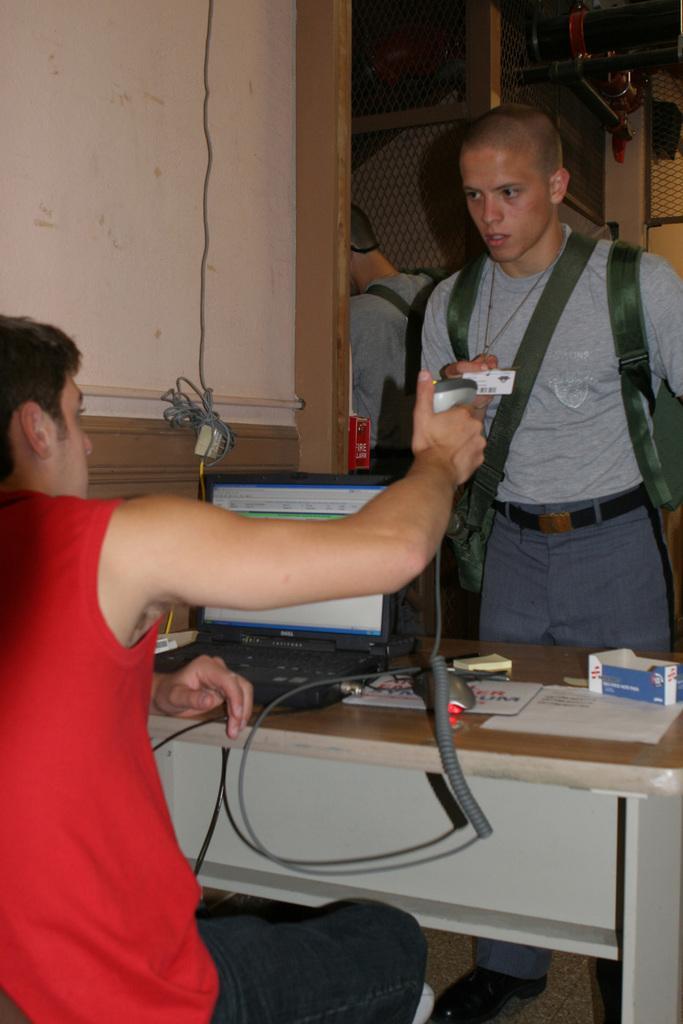Describe this image in one or two sentences. In this picture there is a man standing, there is another person sitting over here. There is a table in front of them with some papers and a small carton box, a laptop and on to the left side there is a wall 